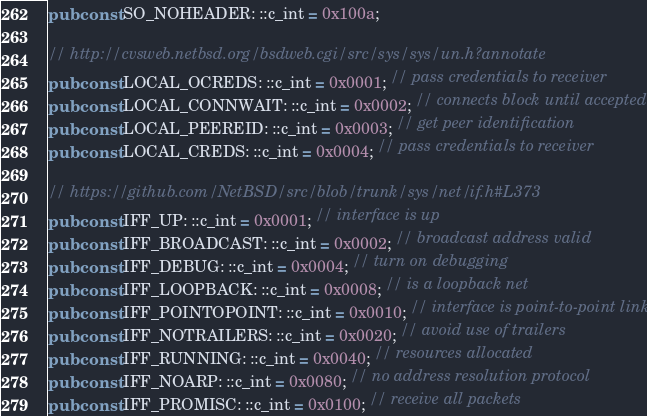Convert code to text. <code><loc_0><loc_0><loc_500><loc_500><_Rust_>pub const SO_NOHEADER: ::c_int = 0x100a;

// http://cvsweb.netbsd.org/bsdweb.cgi/src/sys/sys/un.h?annotate
pub const LOCAL_OCREDS: ::c_int = 0x0001; // pass credentials to receiver
pub const LOCAL_CONNWAIT: ::c_int = 0x0002; // connects block until accepted
pub const LOCAL_PEEREID: ::c_int = 0x0003; // get peer identification
pub const LOCAL_CREDS: ::c_int = 0x0004; // pass credentials to receiver

// https://github.com/NetBSD/src/blob/trunk/sys/net/if.h#L373
pub const IFF_UP: ::c_int = 0x0001; // interface is up
pub const IFF_BROADCAST: ::c_int = 0x0002; // broadcast address valid
pub const IFF_DEBUG: ::c_int = 0x0004; // turn on debugging
pub const IFF_LOOPBACK: ::c_int = 0x0008; // is a loopback net
pub const IFF_POINTOPOINT: ::c_int = 0x0010; // interface is point-to-point link
pub const IFF_NOTRAILERS: ::c_int = 0x0020; // avoid use of trailers
pub const IFF_RUNNING: ::c_int = 0x0040; // resources allocated
pub const IFF_NOARP: ::c_int = 0x0080; // no address resolution protocol
pub const IFF_PROMISC: ::c_int = 0x0100; // receive all packets</code> 